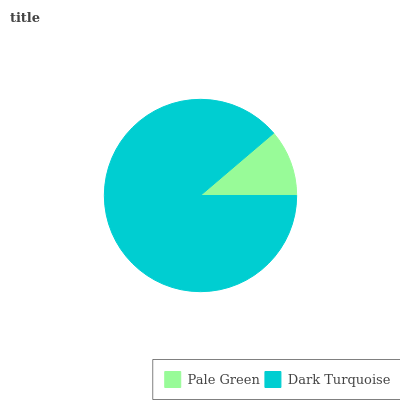Is Pale Green the minimum?
Answer yes or no. Yes. Is Dark Turquoise the maximum?
Answer yes or no. Yes. Is Dark Turquoise the minimum?
Answer yes or no. No. Is Dark Turquoise greater than Pale Green?
Answer yes or no. Yes. Is Pale Green less than Dark Turquoise?
Answer yes or no. Yes. Is Pale Green greater than Dark Turquoise?
Answer yes or no. No. Is Dark Turquoise less than Pale Green?
Answer yes or no. No. Is Dark Turquoise the high median?
Answer yes or no. Yes. Is Pale Green the low median?
Answer yes or no. Yes. Is Pale Green the high median?
Answer yes or no. No. Is Dark Turquoise the low median?
Answer yes or no. No. 